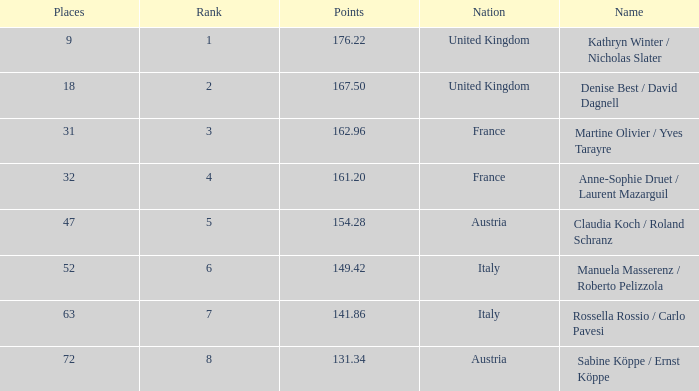Who has points larger than 167.5? Kathryn Winter / Nicholas Slater. 